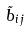Convert formula to latex. <formula><loc_0><loc_0><loc_500><loc_500>\tilde { b } _ { i j }</formula> 